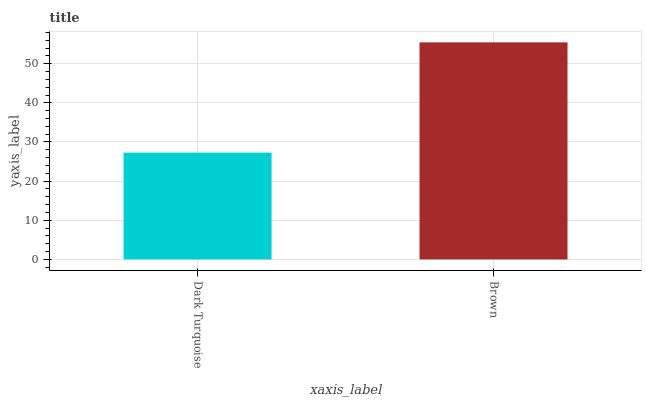Is Dark Turquoise the minimum?
Answer yes or no. Yes. Is Brown the maximum?
Answer yes or no. Yes. Is Brown the minimum?
Answer yes or no. No. Is Brown greater than Dark Turquoise?
Answer yes or no. Yes. Is Dark Turquoise less than Brown?
Answer yes or no. Yes. Is Dark Turquoise greater than Brown?
Answer yes or no. No. Is Brown less than Dark Turquoise?
Answer yes or no. No. Is Brown the high median?
Answer yes or no. Yes. Is Dark Turquoise the low median?
Answer yes or no. Yes. Is Dark Turquoise the high median?
Answer yes or no. No. Is Brown the low median?
Answer yes or no. No. 